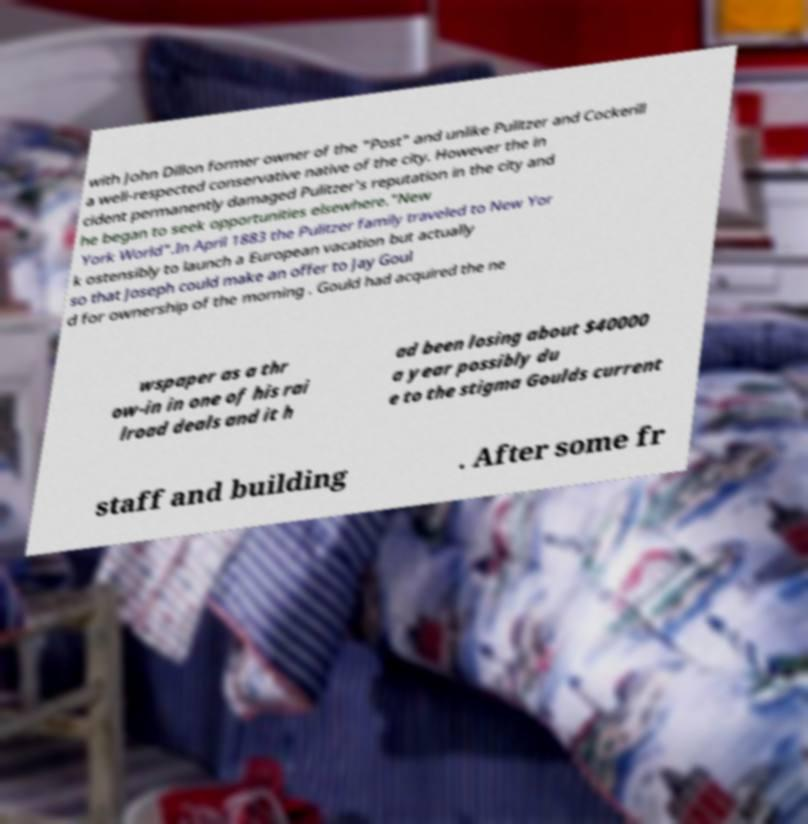For documentation purposes, I need the text within this image transcribed. Could you provide that? with John Dillon former owner of the "Post" and unlike Pulitzer and Cockerill a well-respected conservative native of the city. However the in cident permanently damaged Pulitzer's reputation in the city and he began to seek opportunities elsewhere."New York World".In April 1883 the Pulitzer family traveled to New Yor k ostensibly to launch a European vacation but actually so that Joseph could make an offer to Jay Goul d for ownership of the morning . Gould had acquired the ne wspaper as a thr ow-in in one of his rai lroad deals and it h ad been losing about $40000 a year possibly du e to the stigma Goulds current staff and building . After some fr 